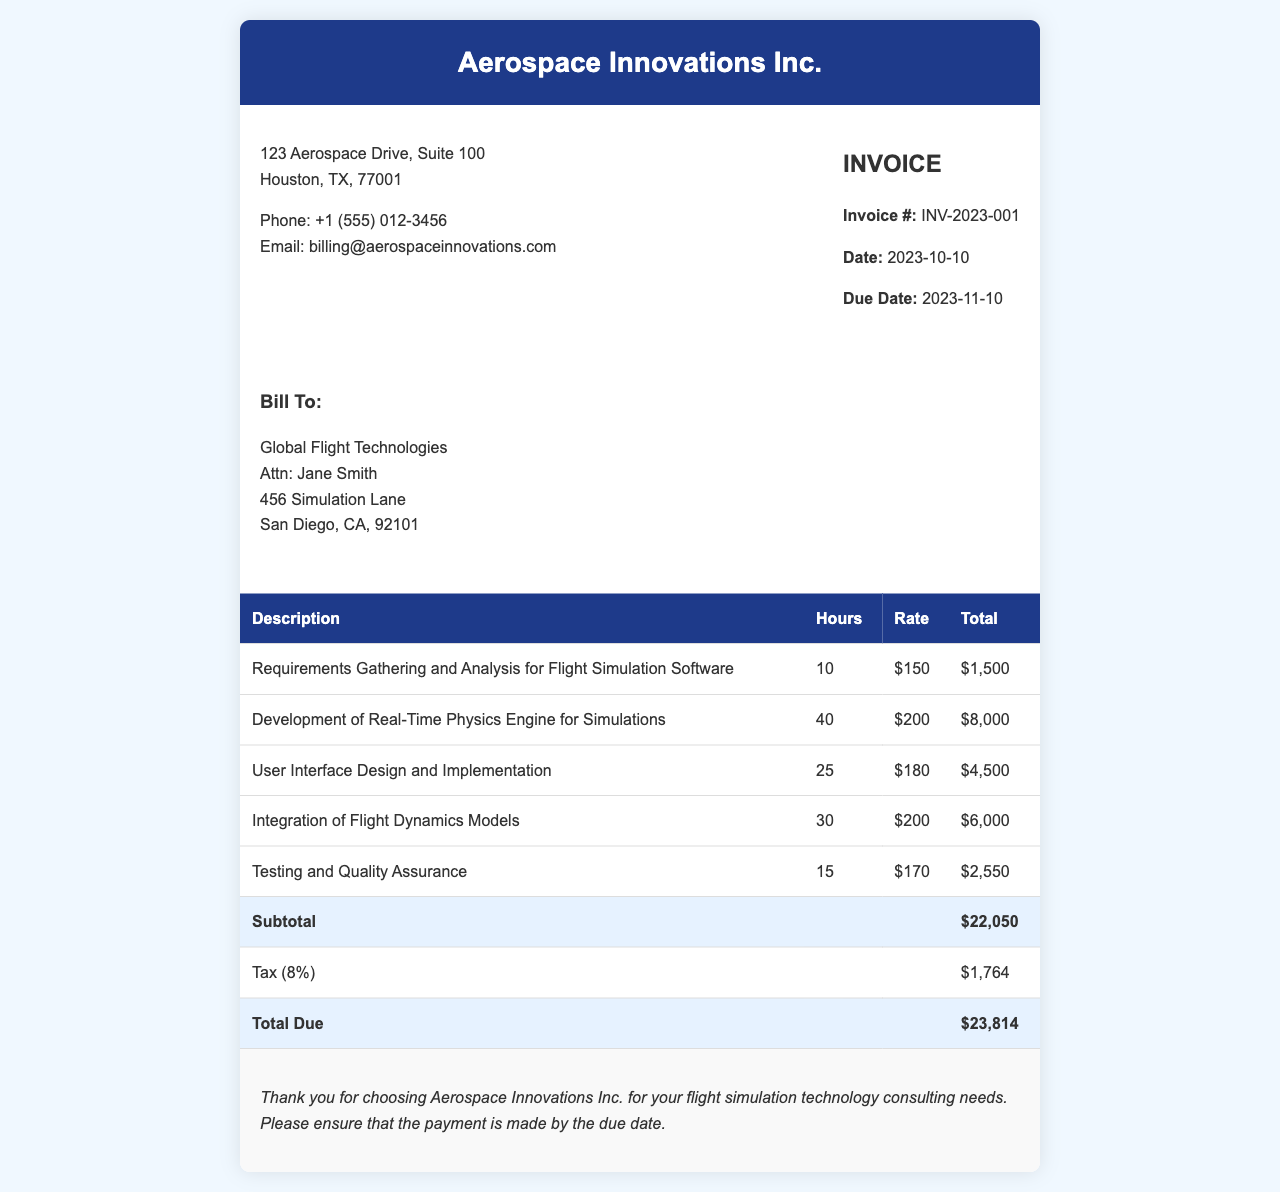What is the invoice number? The invoice number is clearly stated in the document as a unique identifier for this transaction.
Answer: INV-2023-001 What is the total due amount? The total due amount is calculated as the subtotal plus tax.
Answer: $23,814 Who is the client for this invoice? The client for this invoice is the entity receiving the services, mentioned in the document.
Answer: Global Flight Technologies What is the date of the invoice? The date of the invoice is specified to indicate when it was issued.
Answer: 2023-10-10 How many hours were dedicated to user interface design? The document specifies the hours worked on each individual task, including user interface design.
Answer: 25 What percentage of tax is applied? The invoice contains a line indicating the tax rate applied to the subtotal.
Answer: 8% What is the rate for the development of the physics engine? The invoice details the rates for each service provided, including the physics engine development.
Answer: $200 What is the subtotal before tax? The subtotal is the sum of all individual service totals before tax is added.
Answer: $22,050 What is the due date for payment? The document indicates a specific date by which payment should be completed.
Answer: 2023-11-10 